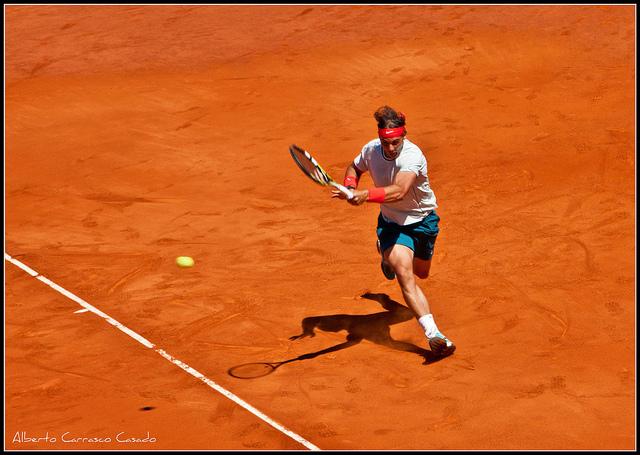Did she just hit the tennis ball?
Concise answer only. Yes. Why does the ball appear blurry?
Quick response, please. Moving. What sport is being played here?
Write a very short answer. Tennis. How can the man ski in this outfit?
Answer briefly. No. What is the color of the pitch?
Quick response, please. Orange. What sport is being played?
Quick response, please. Tennis. What color is the ground?
Answer briefly. Orange. What sport is being played in this picture?
Quick response, please. Tennis. What color is the ball?
Be succinct. Yellow. What piece of sporting equipment is this boy using?
Give a very brief answer. Tennis racket. Is this person praying to a god?
Be succinct. No. What is the texture of the court?
Give a very brief answer. Clay. 